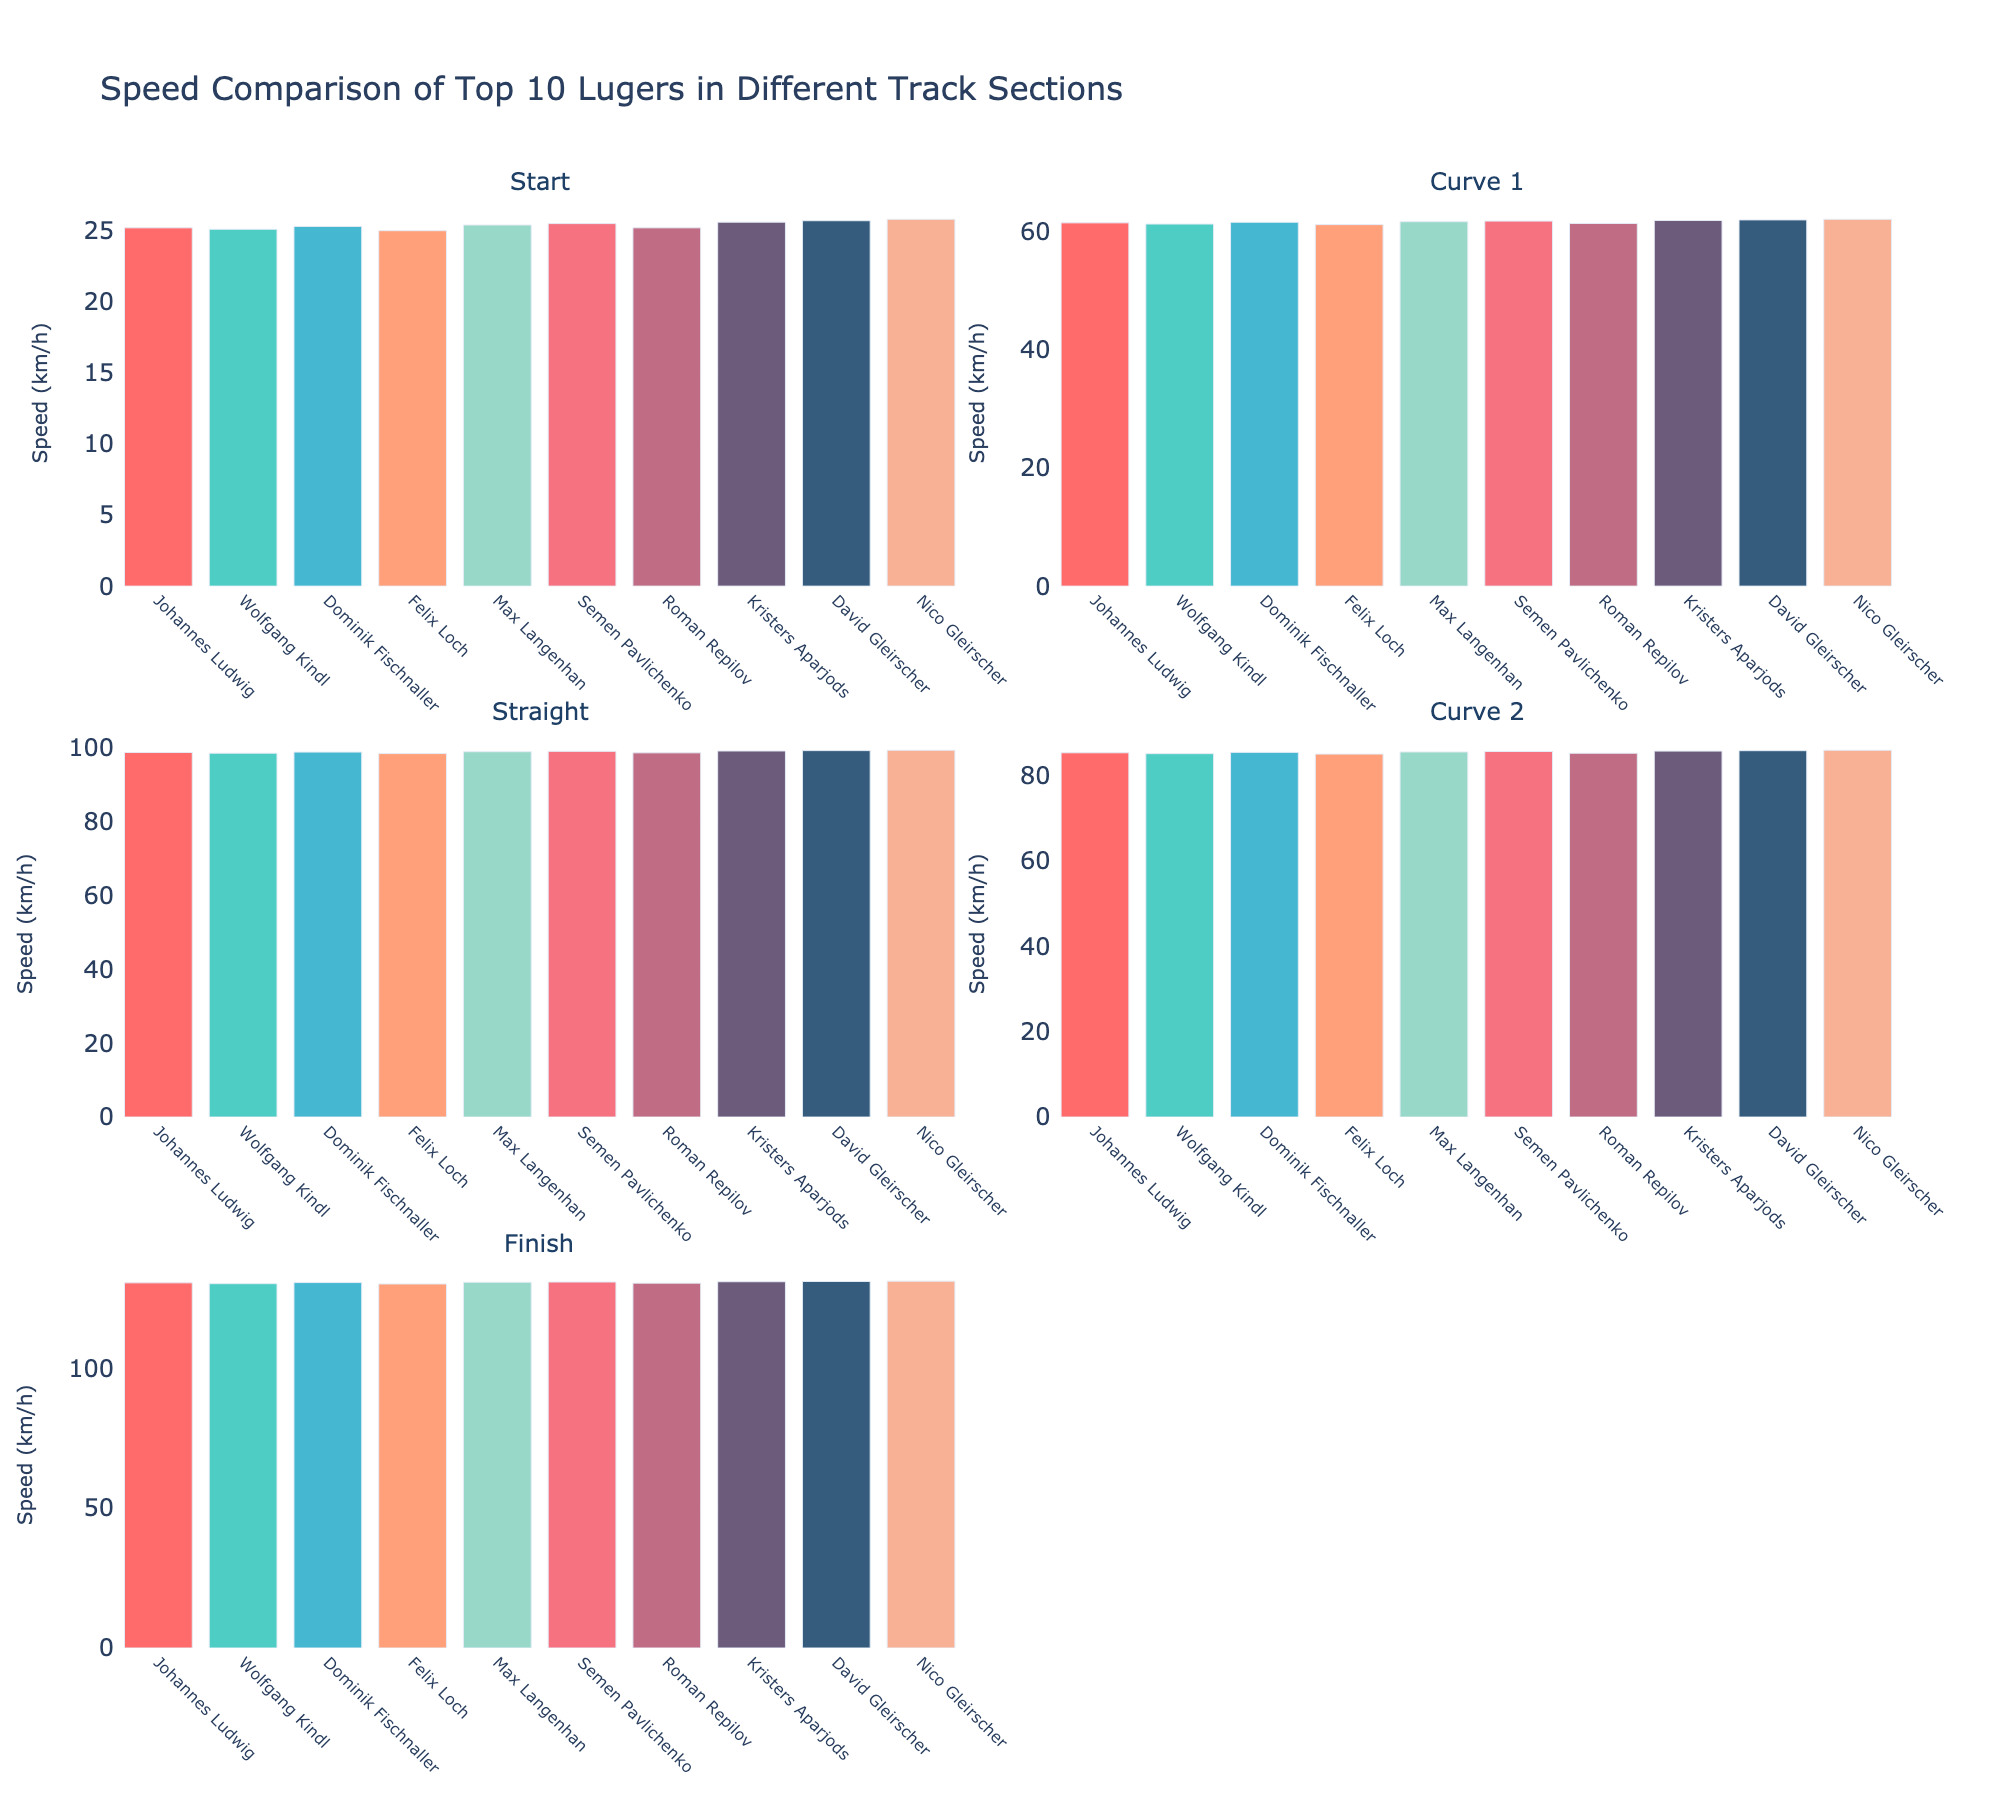How many sections are included in the speed comparison plot? There are five sections in the speed comparison plot as indicated by the subplot titles: 'Start', 'Curve 1', 'Straight', 'Curve 2', and 'Finish'.
Answer: 5 What is the title of the figure? The title is displayed at the top of the figure and reads "Speed Comparison of Top 10 Lugers in Different Track Sections".
Answer: Speed Comparison of Top 10 Lugers in Different Track Sections Which luger has the highest speed at the Finish section? In the Finish section subplot, the bars represent the speed of each luger. The highest bar corresponds to Nico Gleirscher.
Answer: Nico Gleirscher How does the speed trend from the Start to Finish for Johannes Ludwig? By observing the height of the bars for Johannes Ludwig in each subplot, we see that the speeds increase consistently from 'Start' to 'Finish'.
Answer: Increases What is the difference in speed between Max Langenhan and Felix Loch in the Straight section? In the Straight section subplot, Max Langenhan's speed is 98.9 km/h and Felix Loch's speed is 98.4 km/h. The difference is calculated as 98.9 - 98.4 = 0.5 km/h.
Answer: 0.5 km/h Who has the lowest speed in Curve 1, and how does it compare to the highest speed in that section? In Curve 1, the lowest speed is shown by Felix Loch at 61.1 km/h, and the highest speed is by Nico Gleirscher at 62.0 km/h. The difference is 62.0 - 61.1 = 0.9 km/h.
Answer: Felix Loch; 0.9 km/h difference What is the average speed in the Straight section among the top 10 lugers? Summing up the speeds in the Straight section: 98.7 + 98.5 + 98.8 + 98.4 + 98.9 + 99.0 + 98.6 + 99.1 + 99.2 + 99.3 = 988.5. The average is 988.5/10 = 98.85 km/h.
Answer: 98.85 km/h Which luger shows the most consistent speed across all sections, and how can you determine this by looking at the plot? Consistent speed can be observed if the bars in each section are nearly the same height. Johannes Ludwig's bars appear to be very even across all sections.
Answer: Johannes Ludwig How much faster is David Gleirscher at the Finish compared to at the Start? David Gleirscher's speeds are 25.7 km/h at the Start and 131.0 km/h at the Finish. The difference is 131.0 - 25.7 = 105.3 km/h.
Answer: 105.3 km/h 